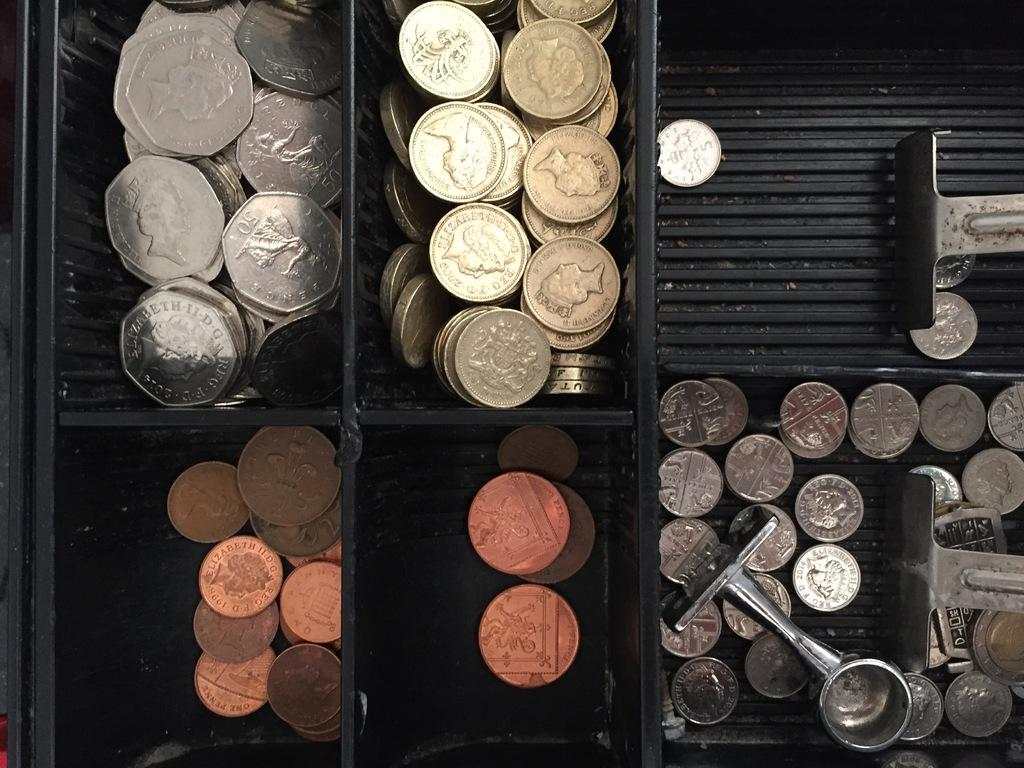<image>
Offer a succinct explanation of the picture presented. Coins in a cash drawer have pictures of Elizabeth on them. 